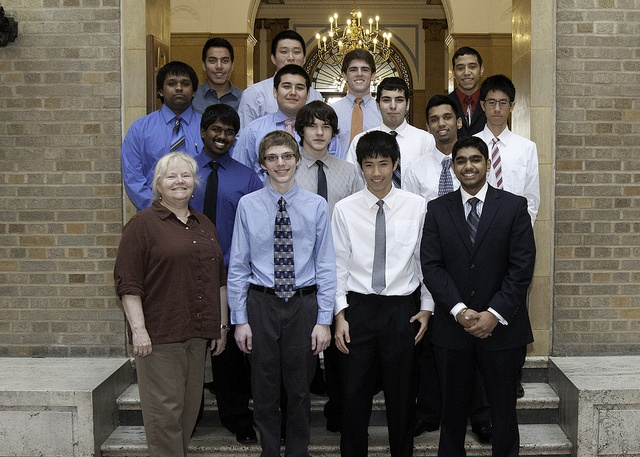Describe the objects in this image and their specific colors. I can see people in darkgray, black, and gray tones, people in darkgray, black, gray, lightgray, and maroon tones, people in darkgray, black, and gray tones, people in darkgray, black, lightgray, and gray tones, and people in darkgray, blue, black, and gray tones in this image. 